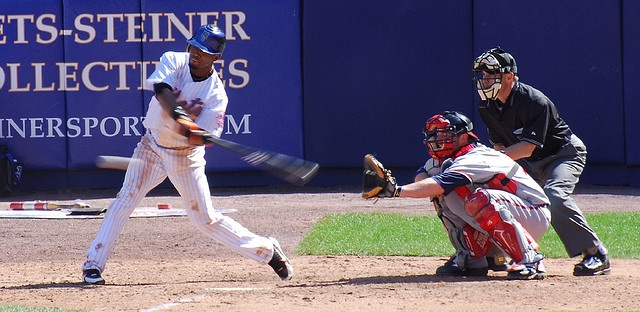Describe the objects in this image and their specific colors. I can see people in darkblue, black, white, maroon, and gray tones, people in darkblue, darkgray, white, and pink tones, people in darkblue, black, gray, lightgray, and darkgray tones, baseball bat in darkblue, navy, gray, and black tones, and baseball glove in darkblue, black, gray, maroon, and brown tones in this image. 